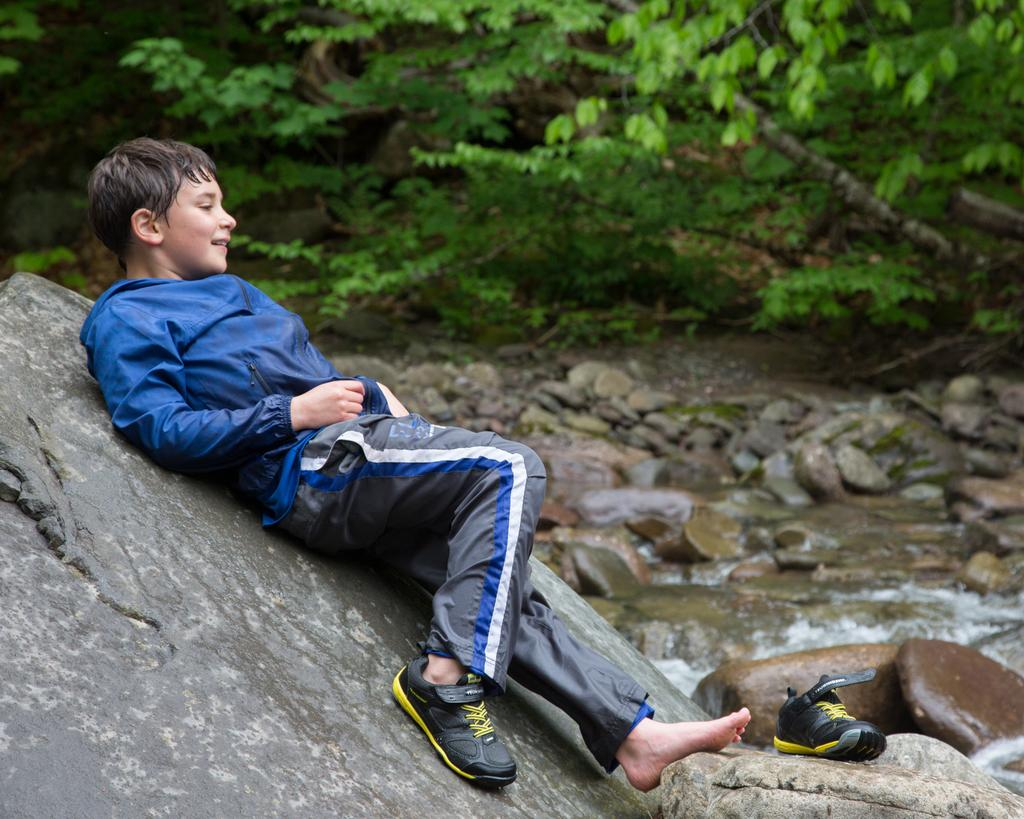What is the boy doing in the image? The boy is lying on a rock on the left side of the image. What object can be seen on a stone in the image? There is a shoe on a stone in the image. What can be seen in the water in the background of the image? There are stones in the water in the background of the image. What type of vegetation is visible in the background of the image? There are trees visible in the background of the image. What type of cork can be seen floating in the water in the image? There is no cork present in the image; only stones can be seen in the water. 